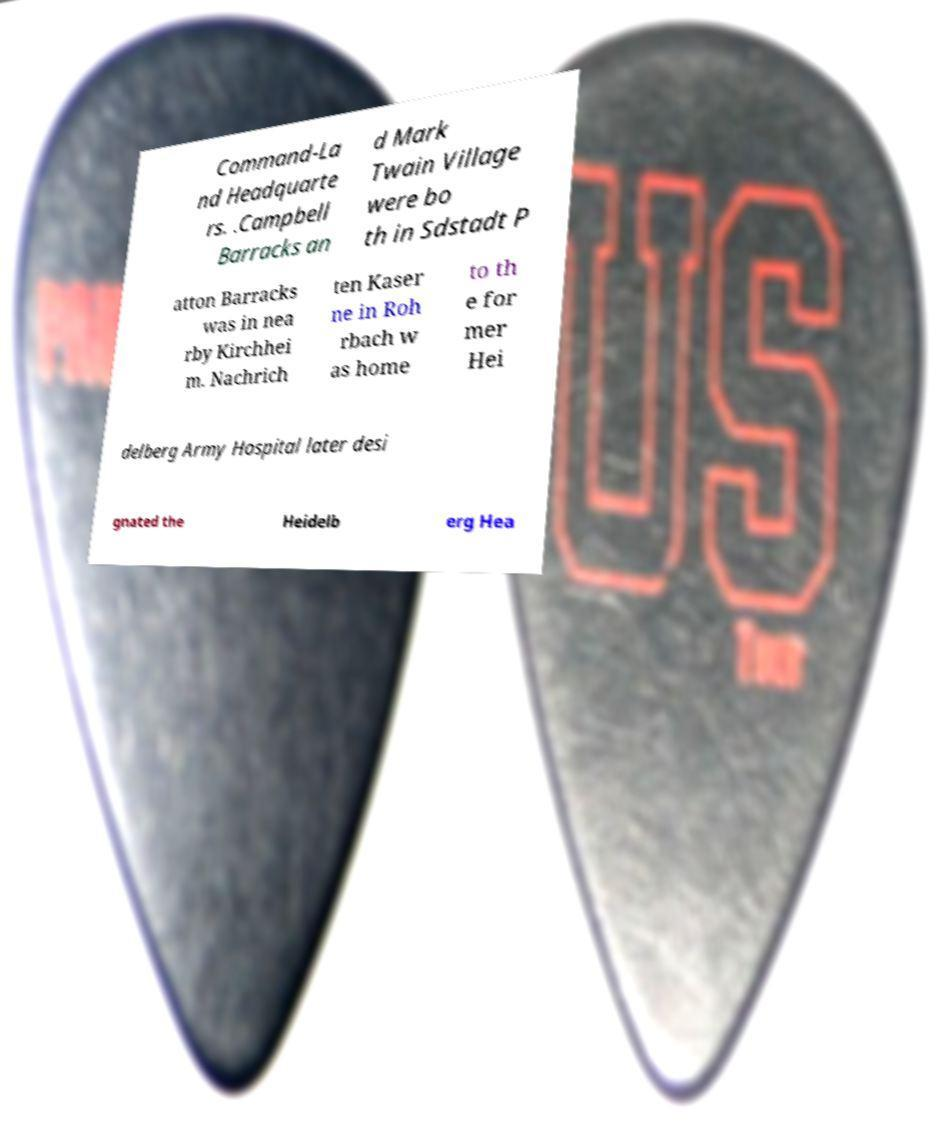There's text embedded in this image that I need extracted. Can you transcribe it verbatim? Command-La nd Headquarte rs. .Campbell Barracks an d Mark Twain Village were bo th in Sdstadt P atton Barracks was in nea rby Kirchhei m. Nachrich ten Kaser ne in Roh rbach w as home to th e for mer Hei delberg Army Hospital later desi gnated the Heidelb erg Hea 